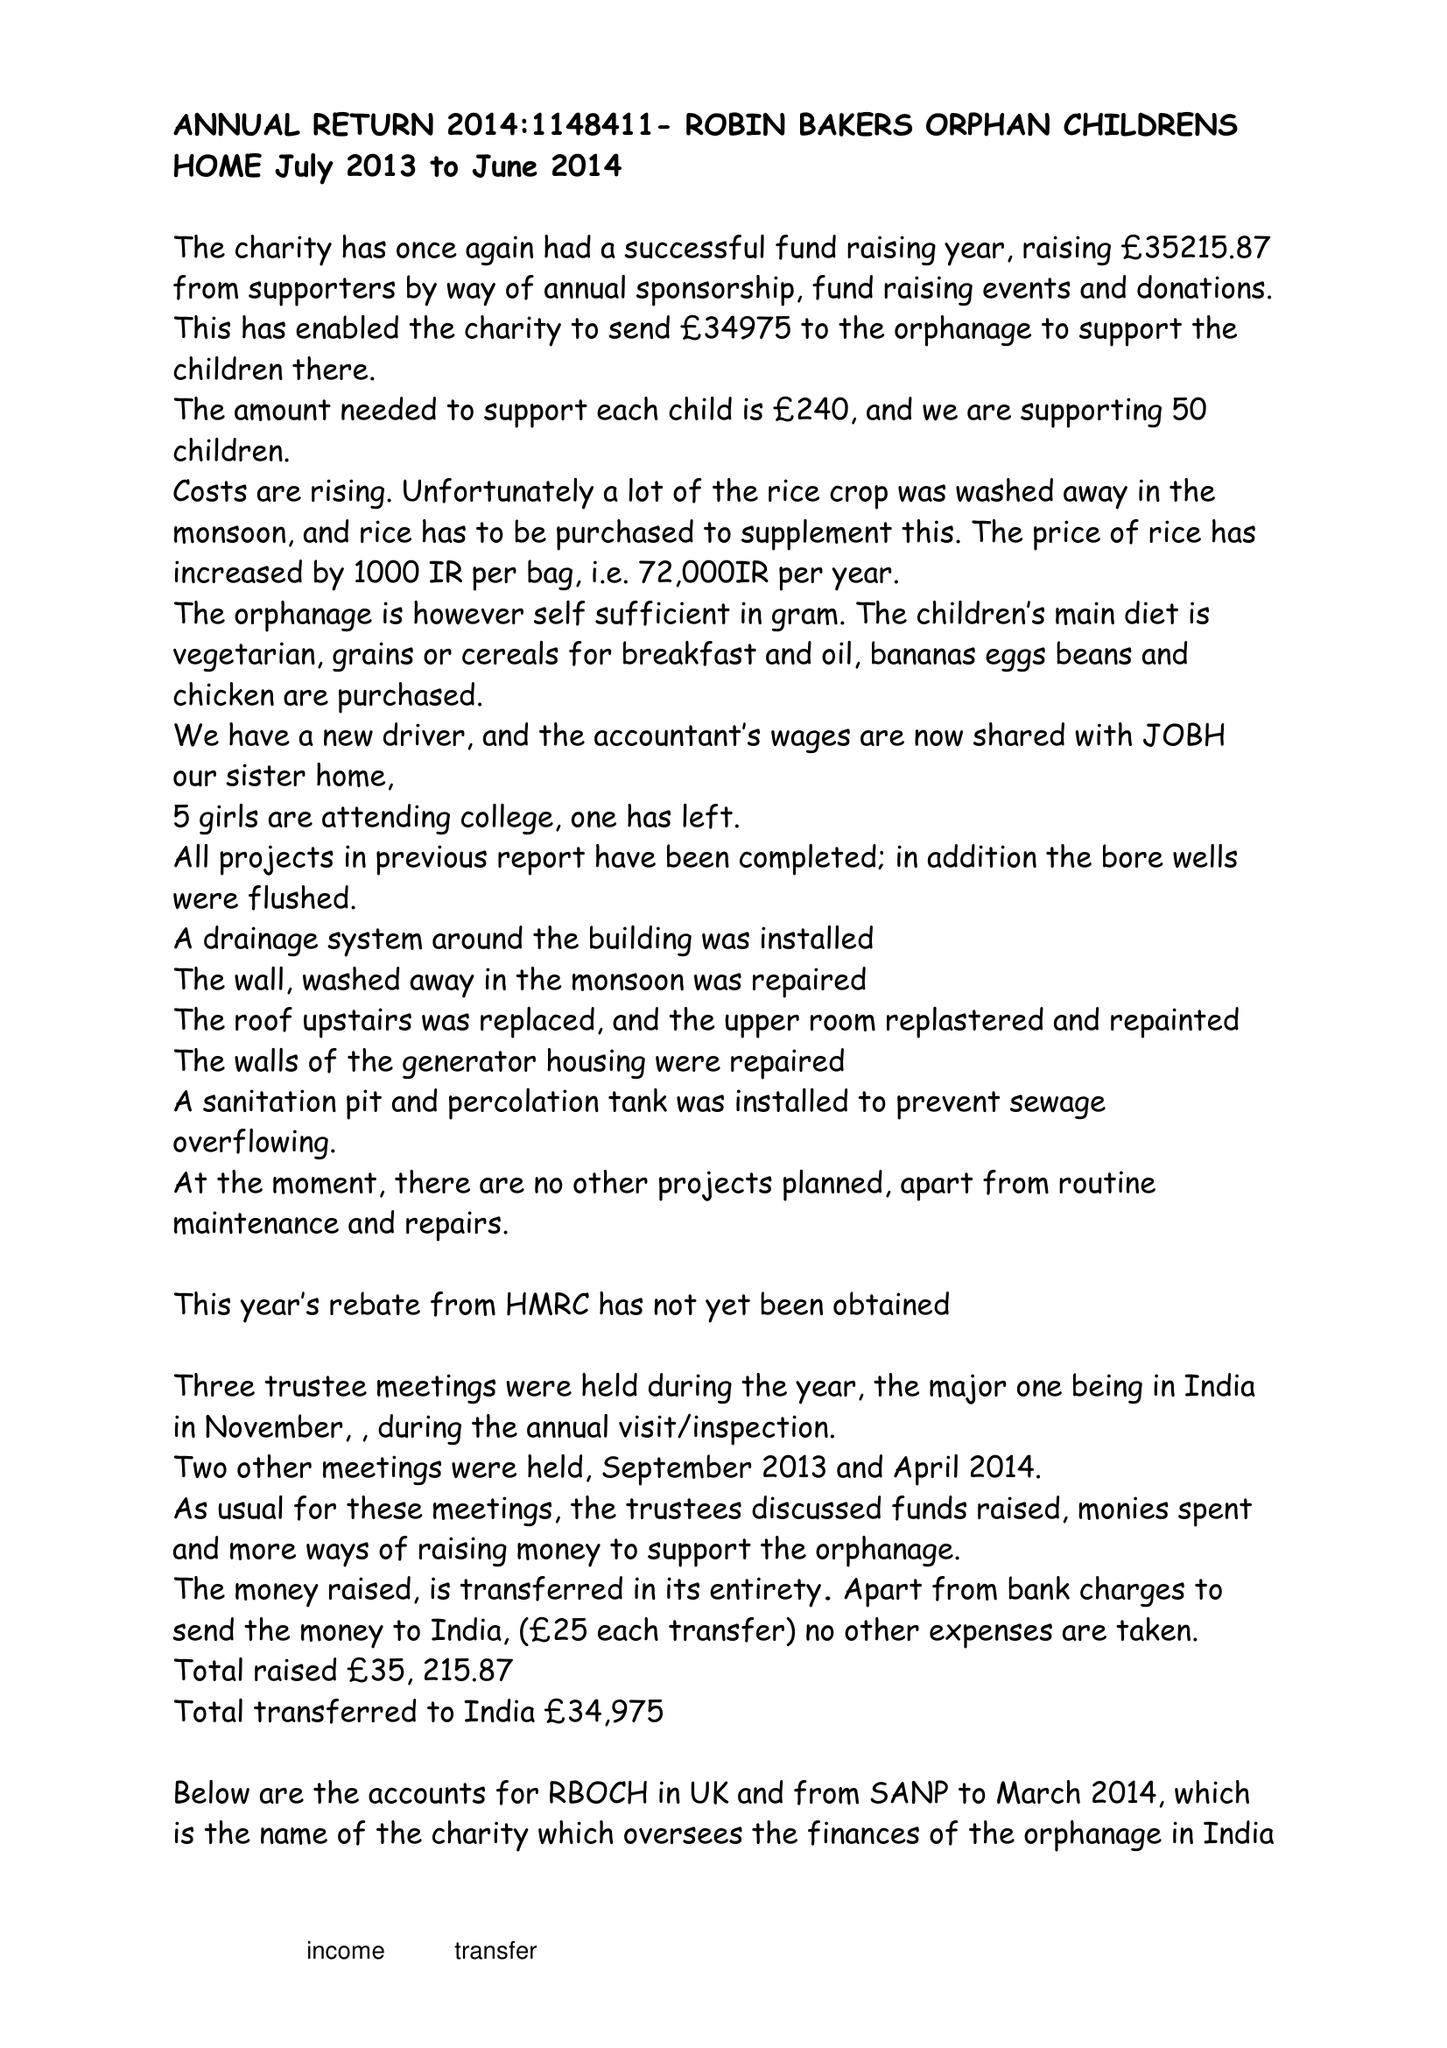What is the value for the address__street_line?
Answer the question using a single word or phrase. RIDGE LANE 